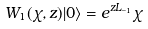Convert formula to latex. <formula><loc_0><loc_0><loc_500><loc_500>W _ { 1 } ( \chi , z ) | 0 \rangle = e ^ { z L _ { - 1 } } \chi</formula> 